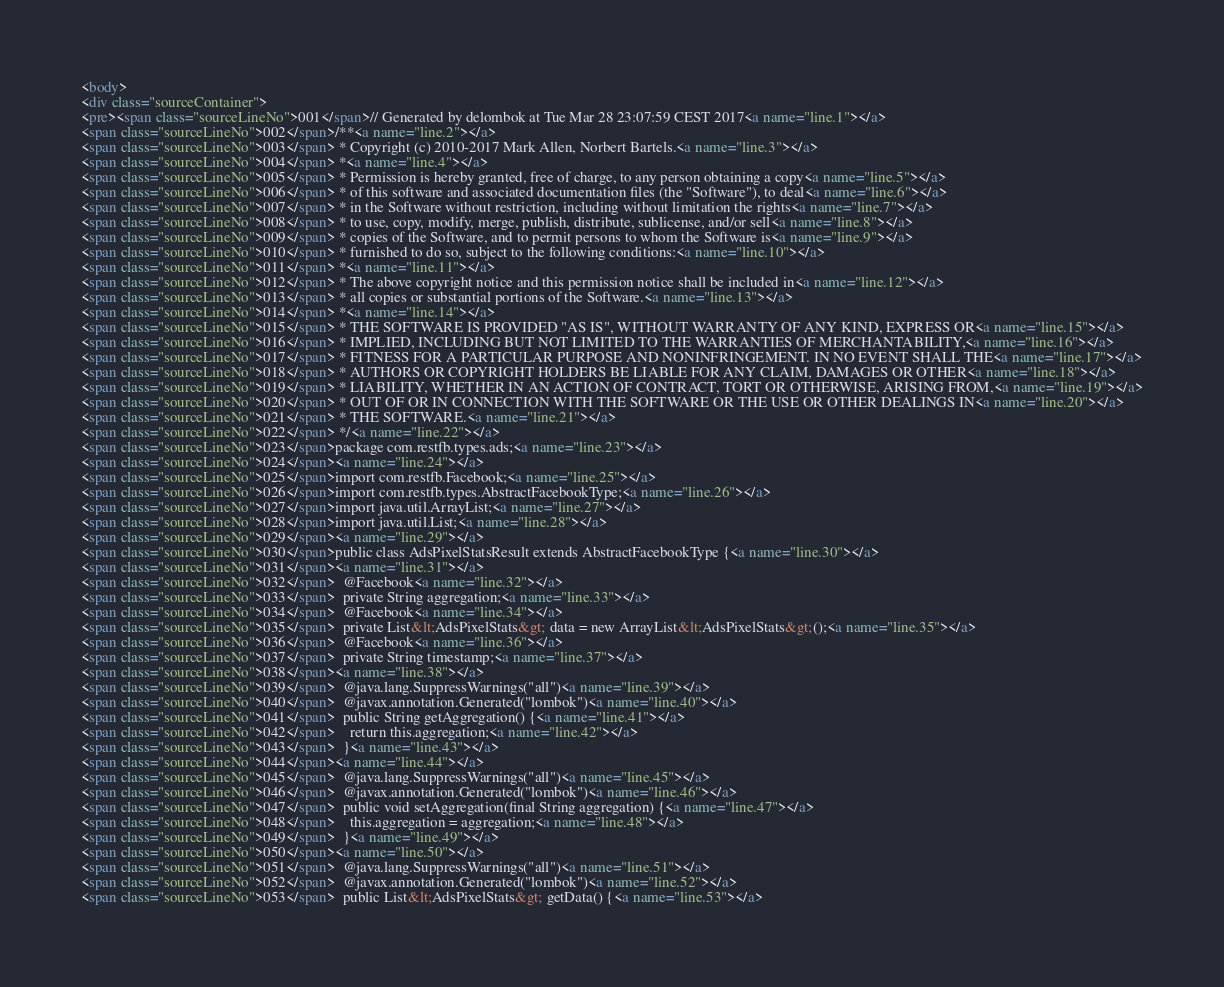<code> <loc_0><loc_0><loc_500><loc_500><_HTML_><body>
<div class="sourceContainer">
<pre><span class="sourceLineNo">001</span>// Generated by delombok at Tue Mar 28 23:07:59 CEST 2017<a name="line.1"></a>
<span class="sourceLineNo">002</span>/**<a name="line.2"></a>
<span class="sourceLineNo">003</span> * Copyright (c) 2010-2017 Mark Allen, Norbert Bartels.<a name="line.3"></a>
<span class="sourceLineNo">004</span> *<a name="line.4"></a>
<span class="sourceLineNo">005</span> * Permission is hereby granted, free of charge, to any person obtaining a copy<a name="line.5"></a>
<span class="sourceLineNo">006</span> * of this software and associated documentation files (the "Software"), to deal<a name="line.6"></a>
<span class="sourceLineNo">007</span> * in the Software without restriction, including without limitation the rights<a name="line.7"></a>
<span class="sourceLineNo">008</span> * to use, copy, modify, merge, publish, distribute, sublicense, and/or sell<a name="line.8"></a>
<span class="sourceLineNo">009</span> * copies of the Software, and to permit persons to whom the Software is<a name="line.9"></a>
<span class="sourceLineNo">010</span> * furnished to do so, subject to the following conditions:<a name="line.10"></a>
<span class="sourceLineNo">011</span> *<a name="line.11"></a>
<span class="sourceLineNo">012</span> * The above copyright notice and this permission notice shall be included in<a name="line.12"></a>
<span class="sourceLineNo">013</span> * all copies or substantial portions of the Software.<a name="line.13"></a>
<span class="sourceLineNo">014</span> *<a name="line.14"></a>
<span class="sourceLineNo">015</span> * THE SOFTWARE IS PROVIDED "AS IS", WITHOUT WARRANTY OF ANY KIND, EXPRESS OR<a name="line.15"></a>
<span class="sourceLineNo">016</span> * IMPLIED, INCLUDING BUT NOT LIMITED TO THE WARRANTIES OF MERCHANTABILITY,<a name="line.16"></a>
<span class="sourceLineNo">017</span> * FITNESS FOR A PARTICULAR PURPOSE AND NONINFRINGEMENT. IN NO EVENT SHALL THE<a name="line.17"></a>
<span class="sourceLineNo">018</span> * AUTHORS OR COPYRIGHT HOLDERS BE LIABLE FOR ANY CLAIM, DAMAGES OR OTHER<a name="line.18"></a>
<span class="sourceLineNo">019</span> * LIABILITY, WHETHER IN AN ACTION OF CONTRACT, TORT OR OTHERWISE, ARISING FROM,<a name="line.19"></a>
<span class="sourceLineNo">020</span> * OUT OF OR IN CONNECTION WITH THE SOFTWARE OR THE USE OR OTHER DEALINGS IN<a name="line.20"></a>
<span class="sourceLineNo">021</span> * THE SOFTWARE.<a name="line.21"></a>
<span class="sourceLineNo">022</span> */<a name="line.22"></a>
<span class="sourceLineNo">023</span>package com.restfb.types.ads;<a name="line.23"></a>
<span class="sourceLineNo">024</span><a name="line.24"></a>
<span class="sourceLineNo">025</span>import com.restfb.Facebook;<a name="line.25"></a>
<span class="sourceLineNo">026</span>import com.restfb.types.AbstractFacebookType;<a name="line.26"></a>
<span class="sourceLineNo">027</span>import java.util.ArrayList;<a name="line.27"></a>
<span class="sourceLineNo">028</span>import java.util.List;<a name="line.28"></a>
<span class="sourceLineNo">029</span><a name="line.29"></a>
<span class="sourceLineNo">030</span>public class AdsPixelStatsResult extends AbstractFacebookType {<a name="line.30"></a>
<span class="sourceLineNo">031</span><a name="line.31"></a>
<span class="sourceLineNo">032</span>  @Facebook<a name="line.32"></a>
<span class="sourceLineNo">033</span>  private String aggregation;<a name="line.33"></a>
<span class="sourceLineNo">034</span>  @Facebook<a name="line.34"></a>
<span class="sourceLineNo">035</span>  private List&lt;AdsPixelStats&gt; data = new ArrayList&lt;AdsPixelStats&gt;();<a name="line.35"></a>
<span class="sourceLineNo">036</span>  @Facebook<a name="line.36"></a>
<span class="sourceLineNo">037</span>  private String timestamp;<a name="line.37"></a>
<span class="sourceLineNo">038</span><a name="line.38"></a>
<span class="sourceLineNo">039</span>  @java.lang.SuppressWarnings("all")<a name="line.39"></a>
<span class="sourceLineNo">040</span>  @javax.annotation.Generated("lombok")<a name="line.40"></a>
<span class="sourceLineNo">041</span>  public String getAggregation() {<a name="line.41"></a>
<span class="sourceLineNo">042</span>    return this.aggregation;<a name="line.42"></a>
<span class="sourceLineNo">043</span>  }<a name="line.43"></a>
<span class="sourceLineNo">044</span><a name="line.44"></a>
<span class="sourceLineNo">045</span>  @java.lang.SuppressWarnings("all")<a name="line.45"></a>
<span class="sourceLineNo">046</span>  @javax.annotation.Generated("lombok")<a name="line.46"></a>
<span class="sourceLineNo">047</span>  public void setAggregation(final String aggregation) {<a name="line.47"></a>
<span class="sourceLineNo">048</span>    this.aggregation = aggregation;<a name="line.48"></a>
<span class="sourceLineNo">049</span>  }<a name="line.49"></a>
<span class="sourceLineNo">050</span><a name="line.50"></a>
<span class="sourceLineNo">051</span>  @java.lang.SuppressWarnings("all")<a name="line.51"></a>
<span class="sourceLineNo">052</span>  @javax.annotation.Generated("lombok")<a name="line.52"></a>
<span class="sourceLineNo">053</span>  public List&lt;AdsPixelStats&gt; getData() {<a name="line.53"></a></code> 